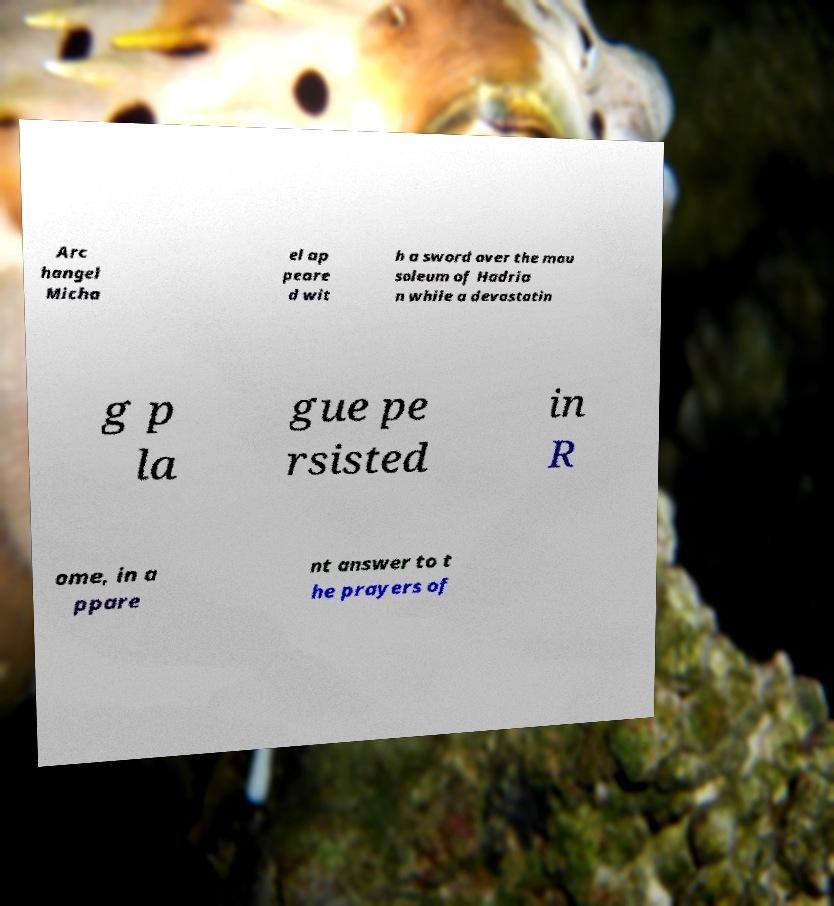There's text embedded in this image that I need extracted. Can you transcribe it verbatim? Arc hangel Micha el ap peare d wit h a sword over the mau soleum of Hadria n while a devastatin g p la gue pe rsisted in R ome, in a ppare nt answer to t he prayers of 